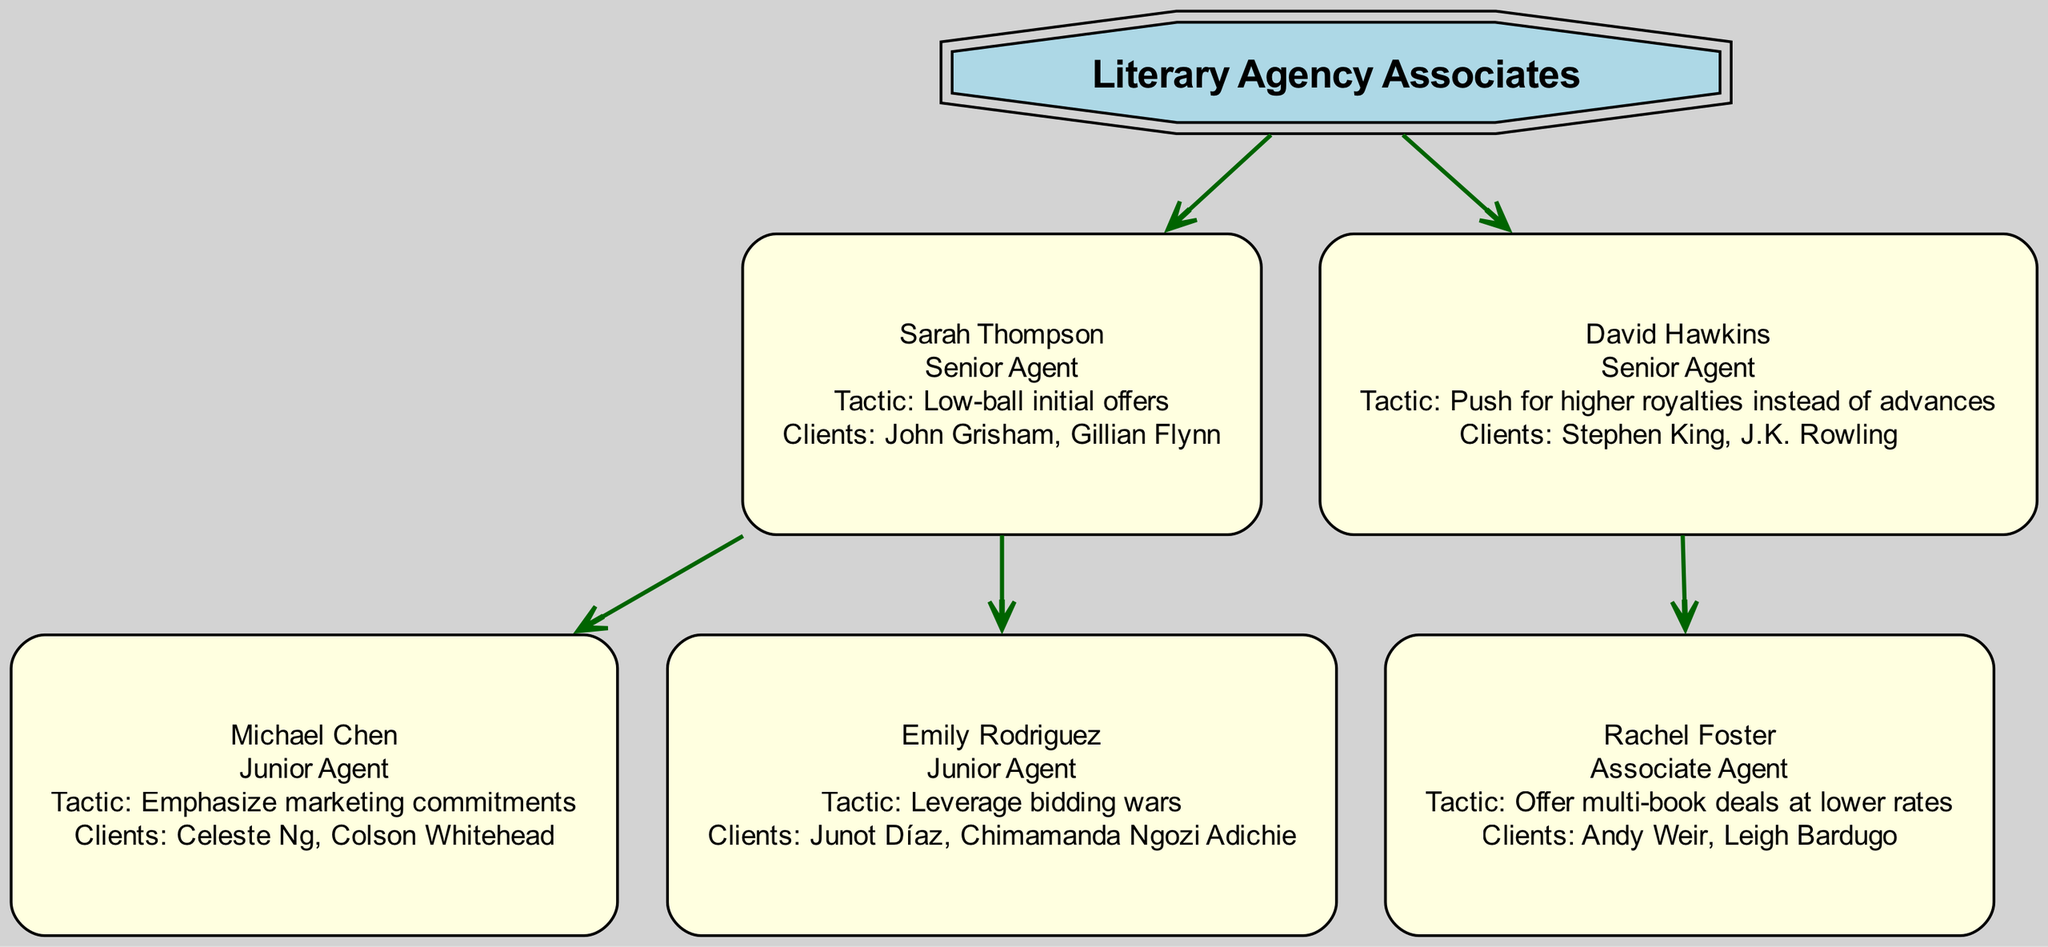What is the name of the root node? The root node in the diagram is labeled "Literary Agency Associates." This is identified as the topmost node without any parents.
Answer: Literary Agency Associates How many Senior Agents are represented in the diagram? The diagram shows two Senior Agents: Sarah Thompson and David Hawkins. By counting the distinct nodes labeled as Senior Agents, we get the answer.
Answer: 2 Which agent has the tactic of "Leverage bidding wars"? Emily Rodriguez is identified as the Junior Agent with that specific tactic. By looking at the children's details under Sarah Thompson, we find Emily Rodriguez listed with her tactic.
Answer: Emily Rodriguez What tactic does David Hawkins employ? The tactic of David Hawkins is "Push for higher royalties instead of advances." This information can be found directly in the description of his node in the diagram.
Answer: Push for higher royalties instead of advances Who are Sarah Thompson's clients? Sarah Thompson represents two clients: John Grisham and Gillian Flynn. This information is specified in the "clients" section of her node.
Answer: John Grisham, Gillian Flynn Which agent has the most clients? Sarah Thompson has the most clients with two listed (John Grisham, Gillian Flynn), while the others have one or two. By comparing the number of clients across all agents, we can determine the answer.
Answer: Sarah Thompson What relationship does Rachel Foster have with David Hawkins? Rachel Foster is identified as an Associate Agent working under David Hawkins, making her a subordinate in the hierarchy. This is clear from the child-parent relationship in the diagram.
Answer: Associate Which clients does Rachel Foster represent? Rachel Foster represents two clients: Andy Weir and Leigh Bardugo. This information is part of the details provided in her node within the diagram.
Answer: Andy Weir, Leigh Bardugo How is Emily Rodriguez related to Sarah Thompson? Emily Rodriguez is a Junior Agent under Sarah Thompson. This relationship can be seen as Emily is listed under Sarah as a child node, indicating a hierarchical relationship.
Answer: Junior Agent Which agent emphasizes marketing commitments as their negotiation tactic? Michael Chen emphasizes marketing commitments. This is specified in his node which highlights his particular negotiation strategy.
Answer: Michael Chen 